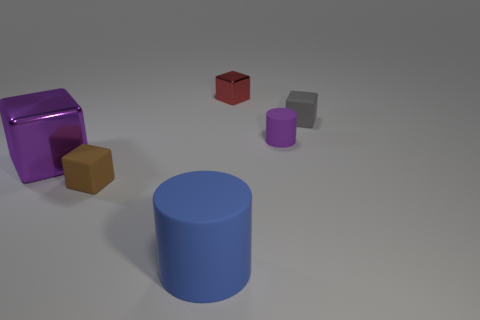Subtract all big purple shiny blocks. How many blocks are left? 3 Subtract 2 cubes. How many cubes are left? 2 Add 3 large purple blocks. How many objects exist? 9 Subtract all blue cylinders. How many cylinders are left? 1 Subtract 1 purple cylinders. How many objects are left? 5 Subtract all cubes. How many objects are left? 2 Subtract all brown cylinders. Subtract all green spheres. How many cylinders are left? 2 Subtract all red cylinders. How many gray blocks are left? 1 Subtract all purple rubber things. Subtract all large blue things. How many objects are left? 4 Add 2 tiny cylinders. How many tiny cylinders are left? 3 